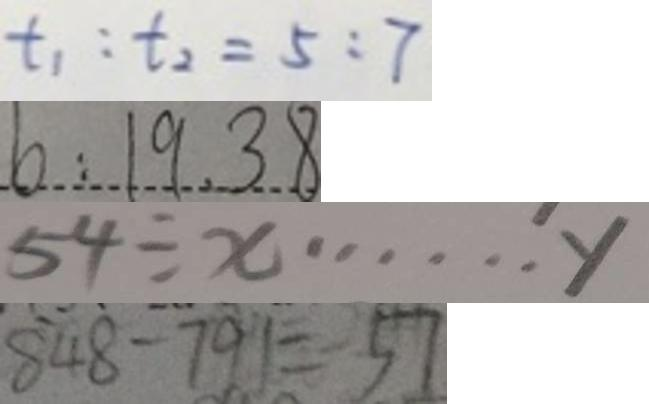Convert formula to latex. <formula><loc_0><loc_0><loc_500><loc_500>t _ { 1 } : t _ { 2 } = 5 : 7 
 b : 1 9 . 3 8 
 5 4 \div x \cdots y 
 8 4 8 - 7 9 1 = 5 7</formula> 